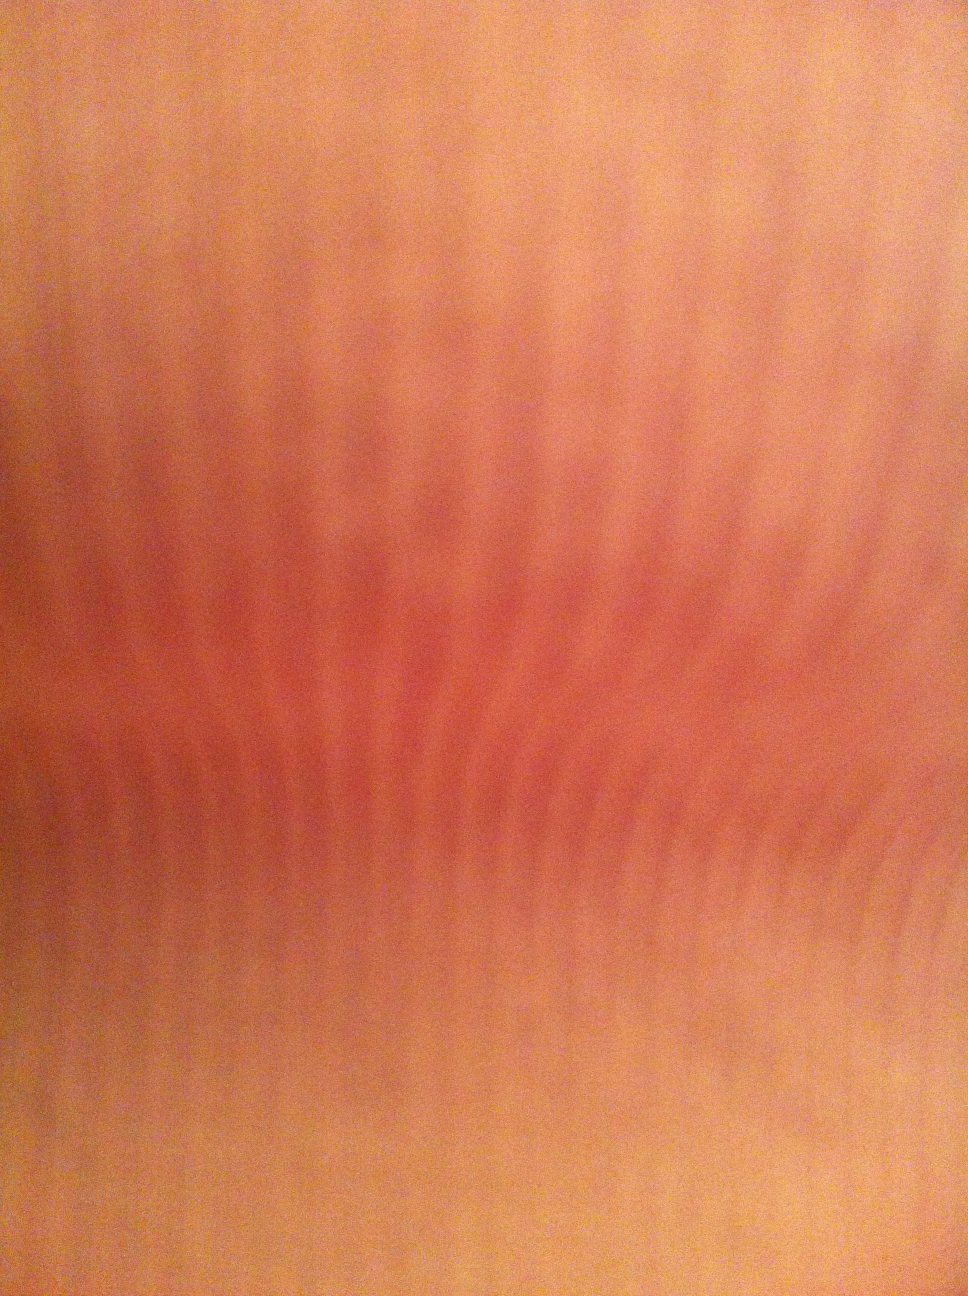Could you guess what part of the body this image might be showing? Given the proximity and the details shown, this image might depict part of a palm or a finger, where such skin patterns and color would be common. 